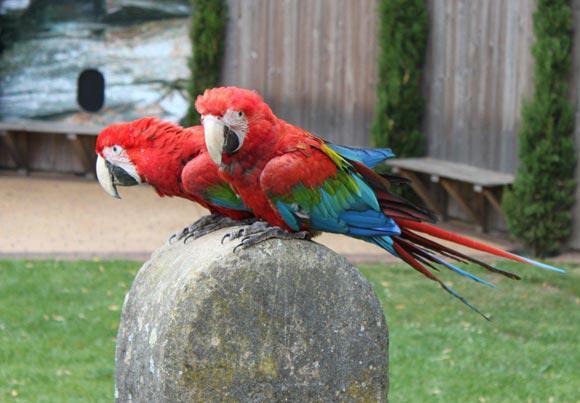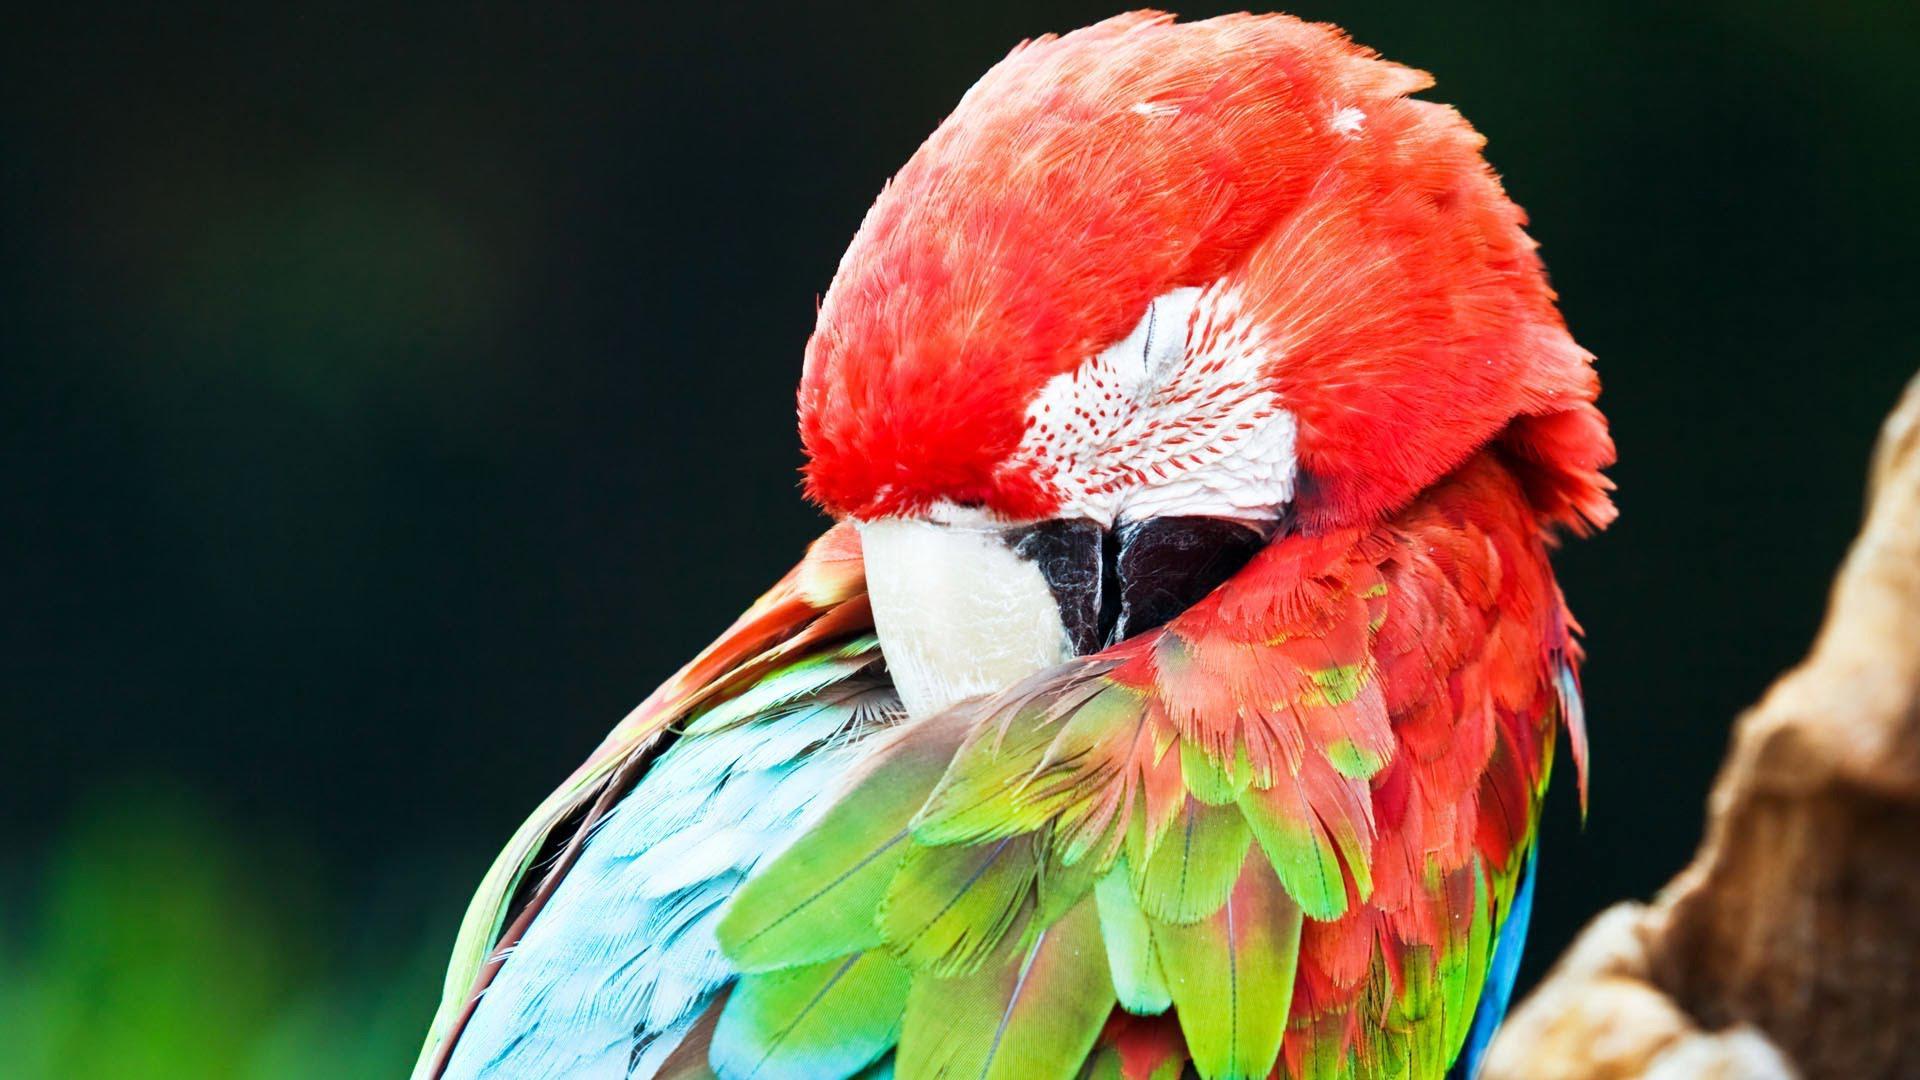The first image is the image on the left, the second image is the image on the right. For the images displayed, is the sentence "The parrot in the right image has a red head." factually correct? Answer yes or no. Yes. The first image is the image on the left, the second image is the image on the right. For the images displayed, is the sentence "A parrot with a red head is sleeping outdoors." factually correct? Answer yes or no. Yes. 